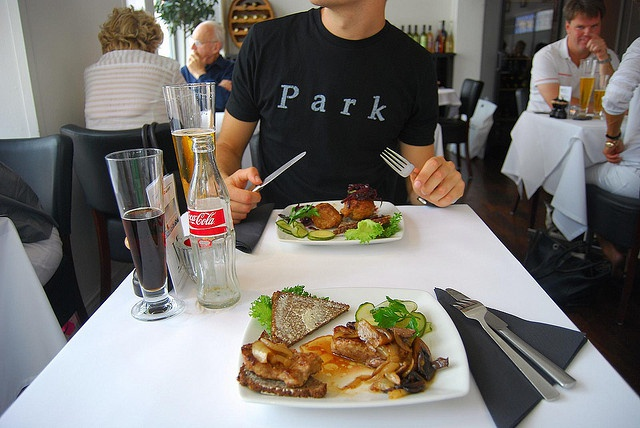Describe the objects in this image and their specific colors. I can see dining table in darkgray, lightgray, black, and brown tones, people in darkgray, black, gray, brown, and tan tones, people in darkgray and gray tones, cup in darkgray, gray, black, and lightgray tones, and chair in darkgray, black, and gray tones in this image. 